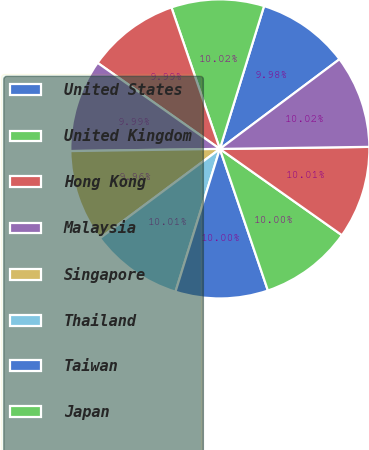<chart> <loc_0><loc_0><loc_500><loc_500><pie_chart><fcel>United States<fcel>United Kingdom<fcel>Hong Kong<fcel>Malaysia<fcel>Singapore<fcel>Thailand<fcel>Taiwan<fcel>Japan<fcel>Korea<fcel>France<nl><fcel>9.98%<fcel>10.02%<fcel>9.99%<fcel>9.99%<fcel>9.96%<fcel>10.01%<fcel>10.0%<fcel>10.0%<fcel>10.01%<fcel>10.02%<nl></chart> 